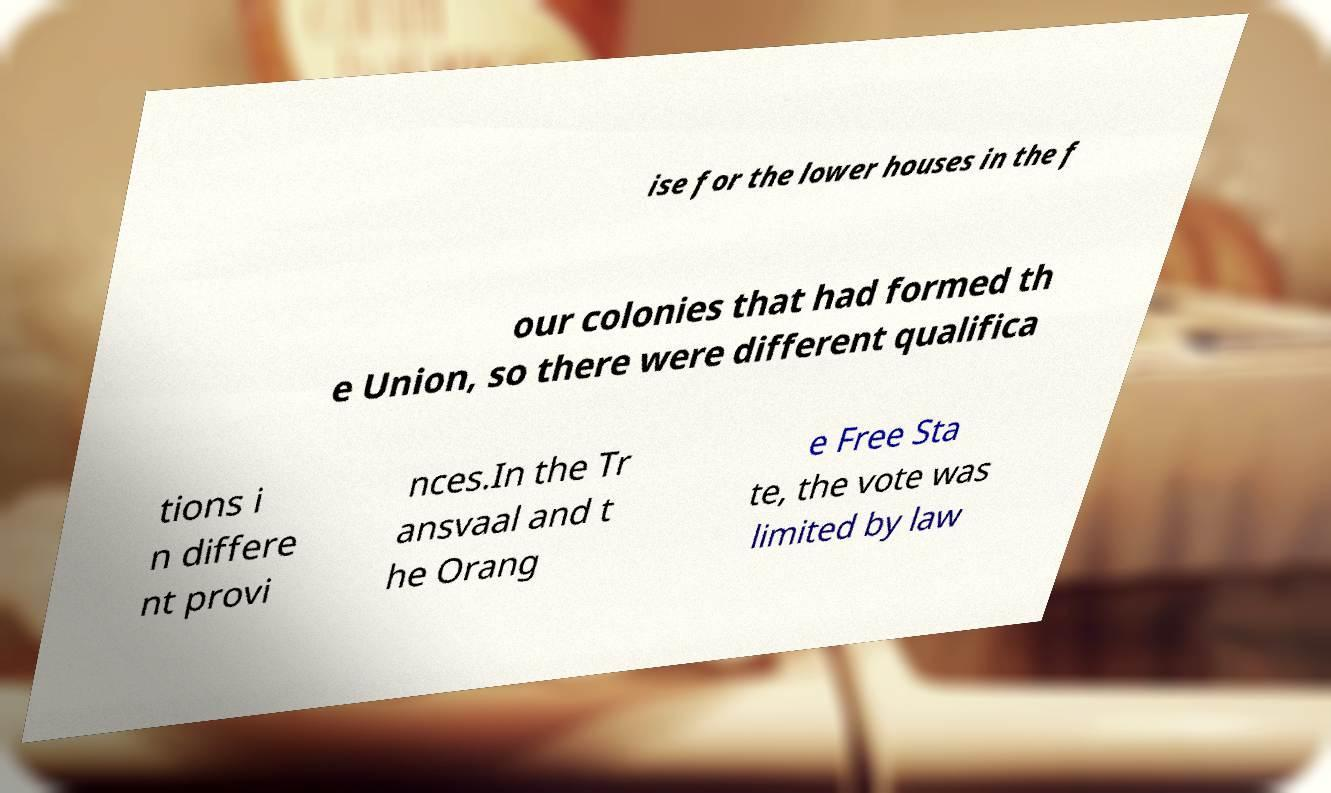There's text embedded in this image that I need extracted. Can you transcribe it verbatim? ise for the lower houses in the f our colonies that had formed th e Union, so there were different qualifica tions i n differe nt provi nces.In the Tr ansvaal and t he Orang e Free Sta te, the vote was limited by law 